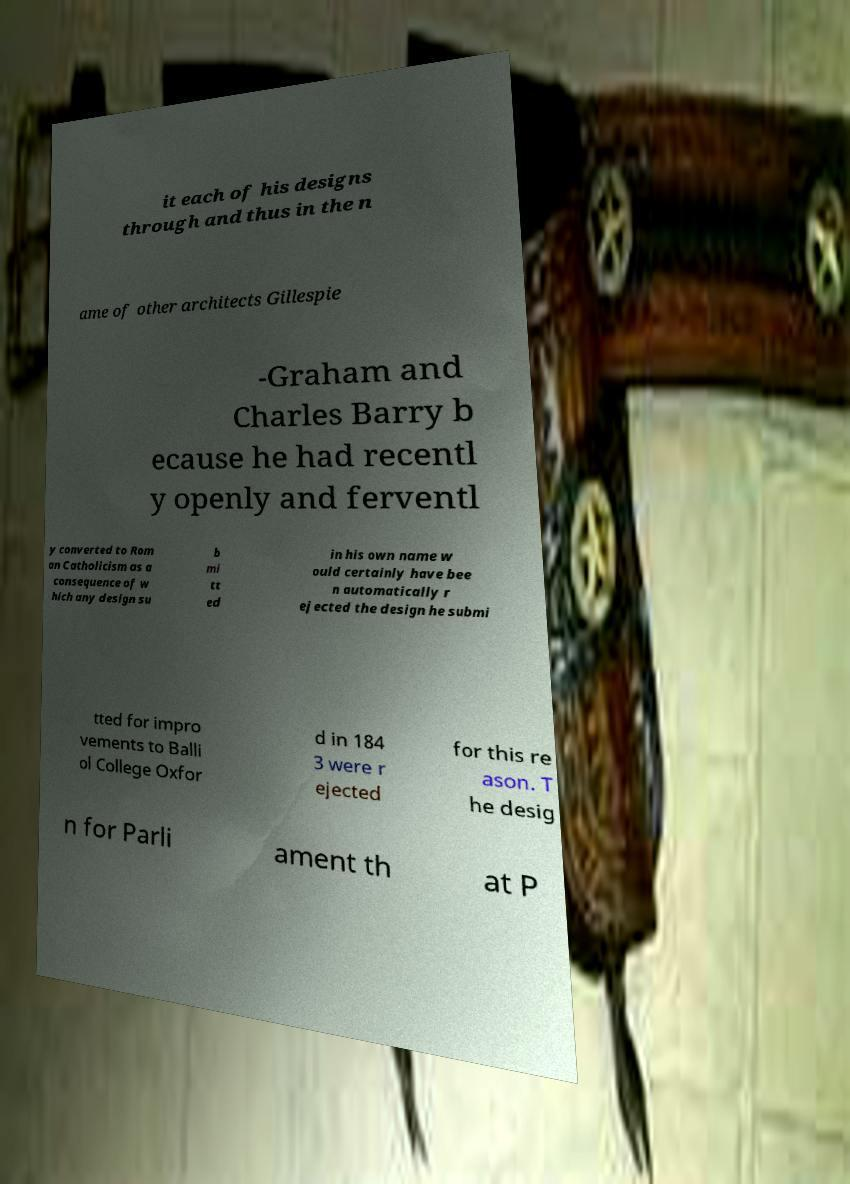Please identify and transcribe the text found in this image. it each of his designs through and thus in the n ame of other architects Gillespie -Graham and Charles Barry b ecause he had recentl y openly and ferventl y converted to Rom an Catholicism as a consequence of w hich any design su b mi tt ed in his own name w ould certainly have bee n automatically r ejected the design he submi tted for impro vements to Balli ol College Oxfor d in 184 3 were r ejected for this re ason. T he desig n for Parli ament th at P 